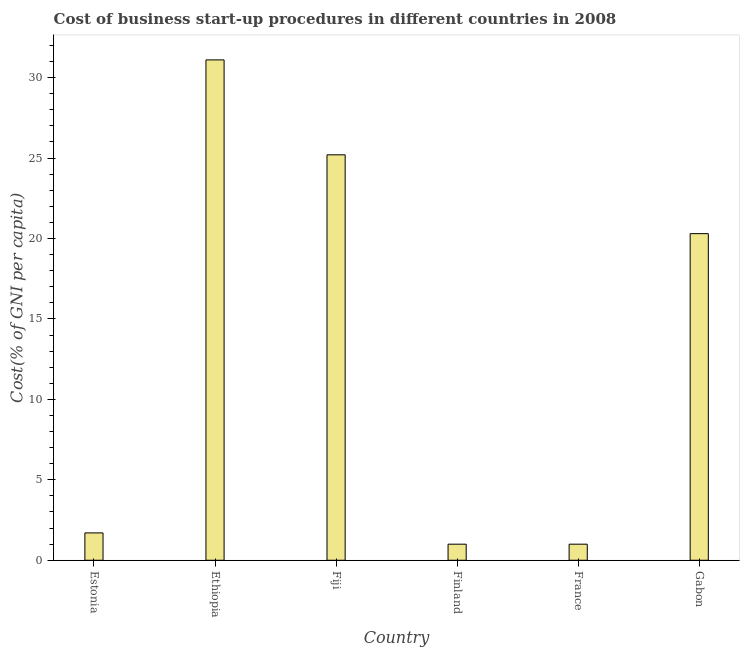What is the title of the graph?
Offer a very short reply. Cost of business start-up procedures in different countries in 2008. What is the label or title of the Y-axis?
Ensure brevity in your answer.  Cost(% of GNI per capita). What is the cost of business startup procedures in Fiji?
Make the answer very short. 25.2. Across all countries, what is the maximum cost of business startup procedures?
Offer a very short reply. 31.1. Across all countries, what is the minimum cost of business startup procedures?
Make the answer very short. 1. In which country was the cost of business startup procedures maximum?
Keep it short and to the point. Ethiopia. In which country was the cost of business startup procedures minimum?
Provide a short and direct response. Finland. What is the sum of the cost of business startup procedures?
Ensure brevity in your answer.  80.3. What is the difference between the cost of business startup procedures in Ethiopia and Finland?
Your response must be concise. 30.1. What is the average cost of business startup procedures per country?
Your answer should be compact. 13.38. What is the median cost of business startup procedures?
Give a very brief answer. 11. What is the ratio of the cost of business startup procedures in Fiji to that in France?
Keep it short and to the point. 25.2. Is the cost of business startup procedures in Ethiopia less than that in Gabon?
Your answer should be compact. No. What is the difference between the highest and the second highest cost of business startup procedures?
Give a very brief answer. 5.9. What is the difference between the highest and the lowest cost of business startup procedures?
Provide a short and direct response. 30.1. Are all the bars in the graph horizontal?
Offer a very short reply. No. How many countries are there in the graph?
Offer a very short reply. 6. What is the Cost(% of GNI per capita) in Estonia?
Provide a short and direct response. 1.7. What is the Cost(% of GNI per capita) in Ethiopia?
Your answer should be compact. 31.1. What is the Cost(% of GNI per capita) of Fiji?
Provide a succinct answer. 25.2. What is the Cost(% of GNI per capita) in Finland?
Keep it short and to the point. 1. What is the Cost(% of GNI per capita) in France?
Provide a short and direct response. 1. What is the Cost(% of GNI per capita) of Gabon?
Your response must be concise. 20.3. What is the difference between the Cost(% of GNI per capita) in Estonia and Ethiopia?
Your answer should be very brief. -29.4. What is the difference between the Cost(% of GNI per capita) in Estonia and Fiji?
Offer a terse response. -23.5. What is the difference between the Cost(% of GNI per capita) in Estonia and Finland?
Make the answer very short. 0.7. What is the difference between the Cost(% of GNI per capita) in Estonia and Gabon?
Keep it short and to the point. -18.6. What is the difference between the Cost(% of GNI per capita) in Ethiopia and Fiji?
Your answer should be very brief. 5.9. What is the difference between the Cost(% of GNI per capita) in Ethiopia and Finland?
Offer a terse response. 30.1. What is the difference between the Cost(% of GNI per capita) in Ethiopia and France?
Offer a terse response. 30.1. What is the difference between the Cost(% of GNI per capita) in Fiji and Finland?
Your answer should be compact. 24.2. What is the difference between the Cost(% of GNI per capita) in Fiji and France?
Offer a terse response. 24.2. What is the difference between the Cost(% of GNI per capita) in Fiji and Gabon?
Ensure brevity in your answer.  4.9. What is the difference between the Cost(% of GNI per capita) in Finland and France?
Keep it short and to the point. 0. What is the difference between the Cost(% of GNI per capita) in Finland and Gabon?
Your answer should be very brief. -19.3. What is the difference between the Cost(% of GNI per capita) in France and Gabon?
Your answer should be very brief. -19.3. What is the ratio of the Cost(% of GNI per capita) in Estonia to that in Ethiopia?
Give a very brief answer. 0.06. What is the ratio of the Cost(% of GNI per capita) in Estonia to that in Fiji?
Provide a short and direct response. 0.07. What is the ratio of the Cost(% of GNI per capita) in Estonia to that in Finland?
Offer a very short reply. 1.7. What is the ratio of the Cost(% of GNI per capita) in Estonia to that in Gabon?
Provide a short and direct response. 0.08. What is the ratio of the Cost(% of GNI per capita) in Ethiopia to that in Fiji?
Give a very brief answer. 1.23. What is the ratio of the Cost(% of GNI per capita) in Ethiopia to that in Finland?
Your answer should be compact. 31.1. What is the ratio of the Cost(% of GNI per capita) in Ethiopia to that in France?
Offer a very short reply. 31.1. What is the ratio of the Cost(% of GNI per capita) in Ethiopia to that in Gabon?
Make the answer very short. 1.53. What is the ratio of the Cost(% of GNI per capita) in Fiji to that in Finland?
Ensure brevity in your answer.  25.2. What is the ratio of the Cost(% of GNI per capita) in Fiji to that in France?
Ensure brevity in your answer.  25.2. What is the ratio of the Cost(% of GNI per capita) in Fiji to that in Gabon?
Offer a very short reply. 1.24. What is the ratio of the Cost(% of GNI per capita) in Finland to that in Gabon?
Your response must be concise. 0.05. What is the ratio of the Cost(% of GNI per capita) in France to that in Gabon?
Provide a short and direct response. 0.05. 